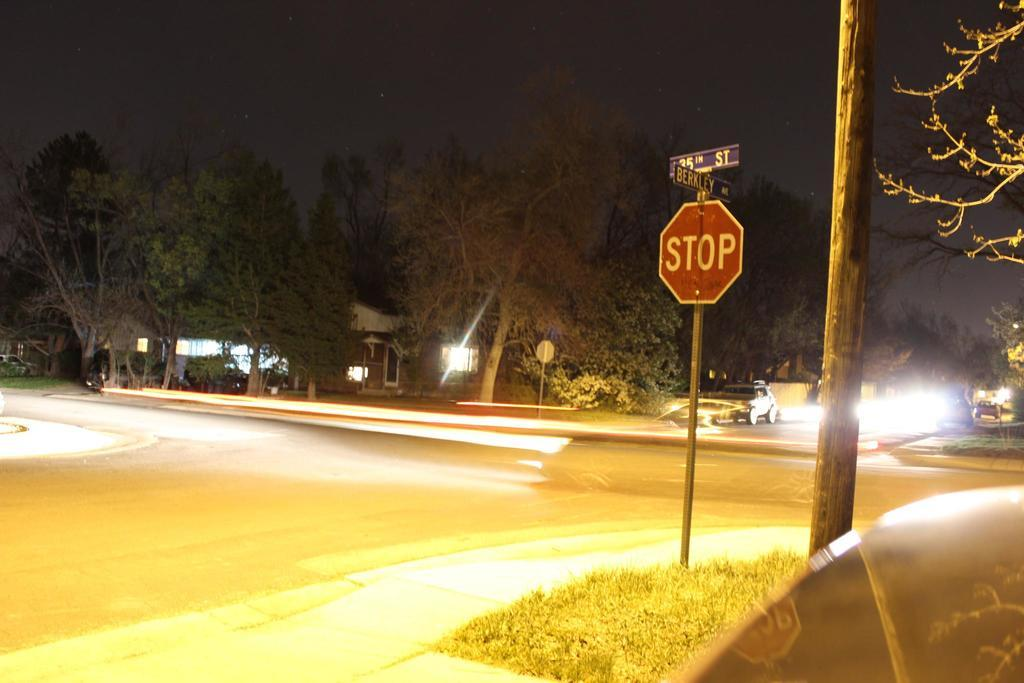<image>
Provide a brief description of the given image. Bright lights shine on a Berkley Ave sign. 